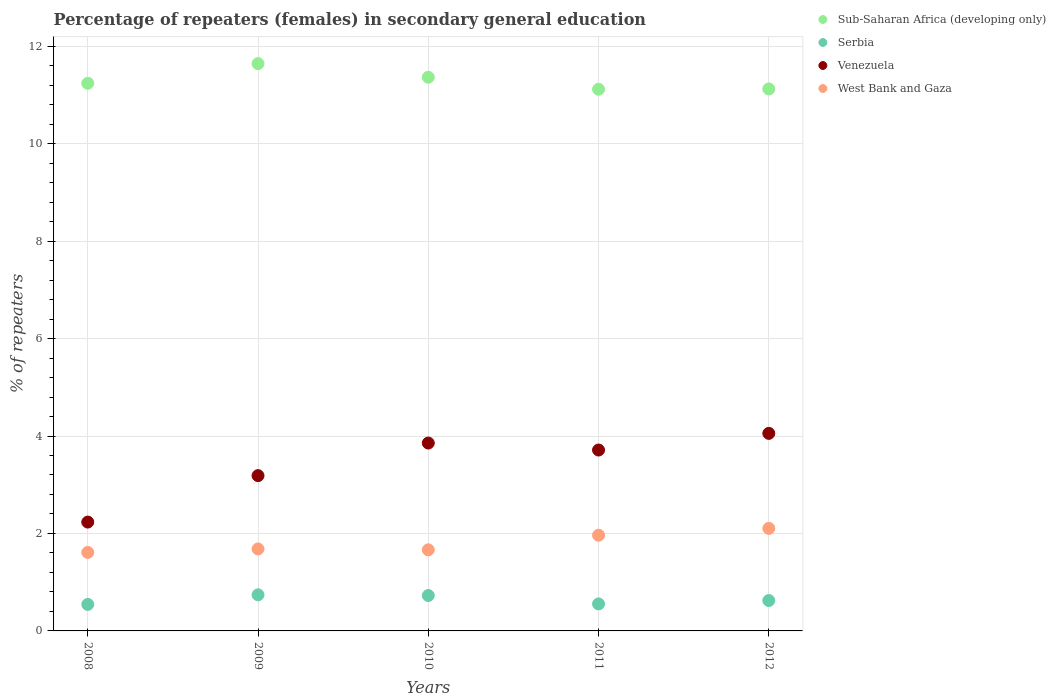How many different coloured dotlines are there?
Make the answer very short. 4. Is the number of dotlines equal to the number of legend labels?
Provide a short and direct response. Yes. What is the percentage of female repeaters in West Bank and Gaza in 2010?
Your answer should be compact. 1.66. Across all years, what is the maximum percentage of female repeaters in Serbia?
Keep it short and to the point. 0.74. Across all years, what is the minimum percentage of female repeaters in Venezuela?
Offer a terse response. 2.23. What is the total percentage of female repeaters in Venezuela in the graph?
Your response must be concise. 17.04. What is the difference between the percentage of female repeaters in West Bank and Gaza in 2009 and that in 2010?
Give a very brief answer. 0.02. What is the difference between the percentage of female repeaters in Serbia in 2012 and the percentage of female repeaters in Venezuela in 2009?
Provide a succinct answer. -2.56. What is the average percentage of female repeaters in Serbia per year?
Provide a succinct answer. 0.64. In the year 2008, what is the difference between the percentage of female repeaters in West Bank and Gaza and percentage of female repeaters in Sub-Saharan Africa (developing only)?
Your answer should be very brief. -9.63. In how many years, is the percentage of female repeaters in Sub-Saharan Africa (developing only) greater than 2.4 %?
Give a very brief answer. 5. What is the ratio of the percentage of female repeaters in West Bank and Gaza in 2009 to that in 2012?
Your response must be concise. 0.8. What is the difference between the highest and the second highest percentage of female repeaters in Sub-Saharan Africa (developing only)?
Make the answer very short. 0.28. What is the difference between the highest and the lowest percentage of female repeaters in West Bank and Gaza?
Provide a short and direct response. 0.49. Is it the case that in every year, the sum of the percentage of female repeaters in West Bank and Gaza and percentage of female repeaters in Sub-Saharan Africa (developing only)  is greater than the sum of percentage of female repeaters in Venezuela and percentage of female repeaters in Serbia?
Offer a very short reply. No. Does the percentage of female repeaters in Sub-Saharan Africa (developing only) monotonically increase over the years?
Provide a succinct answer. No. Is the percentage of female repeaters in Sub-Saharan Africa (developing only) strictly greater than the percentage of female repeaters in Venezuela over the years?
Your answer should be compact. Yes. Is the percentage of female repeaters in West Bank and Gaza strictly less than the percentage of female repeaters in Serbia over the years?
Your response must be concise. No. How many dotlines are there?
Ensure brevity in your answer.  4. How many years are there in the graph?
Your answer should be compact. 5. What is the difference between two consecutive major ticks on the Y-axis?
Provide a succinct answer. 2. Are the values on the major ticks of Y-axis written in scientific E-notation?
Offer a terse response. No. Does the graph contain any zero values?
Keep it short and to the point. No. Does the graph contain grids?
Keep it short and to the point. Yes. How many legend labels are there?
Keep it short and to the point. 4. How are the legend labels stacked?
Your response must be concise. Vertical. What is the title of the graph?
Your answer should be compact. Percentage of repeaters (females) in secondary general education. What is the label or title of the X-axis?
Make the answer very short. Years. What is the label or title of the Y-axis?
Give a very brief answer. % of repeaters. What is the % of repeaters in Sub-Saharan Africa (developing only) in 2008?
Provide a short and direct response. 11.24. What is the % of repeaters of Serbia in 2008?
Your response must be concise. 0.54. What is the % of repeaters in Venezuela in 2008?
Ensure brevity in your answer.  2.23. What is the % of repeaters in West Bank and Gaza in 2008?
Your answer should be compact. 1.61. What is the % of repeaters in Sub-Saharan Africa (developing only) in 2009?
Provide a short and direct response. 11.64. What is the % of repeaters in Serbia in 2009?
Provide a short and direct response. 0.74. What is the % of repeaters in Venezuela in 2009?
Keep it short and to the point. 3.19. What is the % of repeaters in West Bank and Gaza in 2009?
Your answer should be very brief. 1.68. What is the % of repeaters of Sub-Saharan Africa (developing only) in 2010?
Your response must be concise. 11.36. What is the % of repeaters in Serbia in 2010?
Give a very brief answer. 0.73. What is the % of repeaters in Venezuela in 2010?
Give a very brief answer. 3.86. What is the % of repeaters in West Bank and Gaza in 2010?
Offer a very short reply. 1.66. What is the % of repeaters of Sub-Saharan Africa (developing only) in 2011?
Your answer should be compact. 11.12. What is the % of repeaters of Serbia in 2011?
Give a very brief answer. 0.55. What is the % of repeaters in Venezuela in 2011?
Make the answer very short. 3.71. What is the % of repeaters of West Bank and Gaza in 2011?
Make the answer very short. 1.96. What is the % of repeaters of Sub-Saharan Africa (developing only) in 2012?
Give a very brief answer. 11.12. What is the % of repeaters in Serbia in 2012?
Make the answer very short. 0.62. What is the % of repeaters in Venezuela in 2012?
Provide a succinct answer. 4.05. What is the % of repeaters in West Bank and Gaza in 2012?
Your answer should be compact. 2.1. Across all years, what is the maximum % of repeaters of Sub-Saharan Africa (developing only)?
Offer a terse response. 11.64. Across all years, what is the maximum % of repeaters in Serbia?
Provide a short and direct response. 0.74. Across all years, what is the maximum % of repeaters in Venezuela?
Provide a succinct answer. 4.05. Across all years, what is the maximum % of repeaters in West Bank and Gaza?
Keep it short and to the point. 2.1. Across all years, what is the minimum % of repeaters of Sub-Saharan Africa (developing only)?
Ensure brevity in your answer.  11.12. Across all years, what is the minimum % of repeaters of Serbia?
Ensure brevity in your answer.  0.54. Across all years, what is the minimum % of repeaters of Venezuela?
Your response must be concise. 2.23. Across all years, what is the minimum % of repeaters in West Bank and Gaza?
Give a very brief answer. 1.61. What is the total % of repeaters of Sub-Saharan Africa (developing only) in the graph?
Offer a terse response. 56.48. What is the total % of repeaters in Serbia in the graph?
Your answer should be very brief. 3.19. What is the total % of repeaters of Venezuela in the graph?
Offer a very short reply. 17.04. What is the total % of repeaters in West Bank and Gaza in the graph?
Offer a very short reply. 9.03. What is the difference between the % of repeaters in Sub-Saharan Africa (developing only) in 2008 and that in 2009?
Provide a short and direct response. -0.4. What is the difference between the % of repeaters of Serbia in 2008 and that in 2009?
Make the answer very short. -0.2. What is the difference between the % of repeaters in Venezuela in 2008 and that in 2009?
Ensure brevity in your answer.  -0.95. What is the difference between the % of repeaters of West Bank and Gaza in 2008 and that in 2009?
Offer a very short reply. -0.07. What is the difference between the % of repeaters in Sub-Saharan Africa (developing only) in 2008 and that in 2010?
Ensure brevity in your answer.  -0.12. What is the difference between the % of repeaters in Serbia in 2008 and that in 2010?
Provide a succinct answer. -0.18. What is the difference between the % of repeaters of Venezuela in 2008 and that in 2010?
Offer a terse response. -1.62. What is the difference between the % of repeaters of West Bank and Gaza in 2008 and that in 2010?
Your response must be concise. -0.05. What is the difference between the % of repeaters of Sub-Saharan Africa (developing only) in 2008 and that in 2011?
Offer a terse response. 0.12. What is the difference between the % of repeaters in Serbia in 2008 and that in 2011?
Provide a short and direct response. -0.01. What is the difference between the % of repeaters in Venezuela in 2008 and that in 2011?
Make the answer very short. -1.48. What is the difference between the % of repeaters in West Bank and Gaza in 2008 and that in 2011?
Your response must be concise. -0.35. What is the difference between the % of repeaters of Sub-Saharan Africa (developing only) in 2008 and that in 2012?
Provide a succinct answer. 0.12. What is the difference between the % of repeaters in Serbia in 2008 and that in 2012?
Your answer should be very brief. -0.08. What is the difference between the % of repeaters in Venezuela in 2008 and that in 2012?
Your response must be concise. -1.82. What is the difference between the % of repeaters of West Bank and Gaza in 2008 and that in 2012?
Your answer should be very brief. -0.49. What is the difference between the % of repeaters of Sub-Saharan Africa (developing only) in 2009 and that in 2010?
Offer a terse response. 0.28. What is the difference between the % of repeaters in Serbia in 2009 and that in 2010?
Ensure brevity in your answer.  0.01. What is the difference between the % of repeaters of Venezuela in 2009 and that in 2010?
Make the answer very short. -0.67. What is the difference between the % of repeaters in West Bank and Gaza in 2009 and that in 2010?
Provide a succinct answer. 0.02. What is the difference between the % of repeaters in Sub-Saharan Africa (developing only) in 2009 and that in 2011?
Provide a succinct answer. 0.53. What is the difference between the % of repeaters of Serbia in 2009 and that in 2011?
Provide a succinct answer. 0.19. What is the difference between the % of repeaters of Venezuela in 2009 and that in 2011?
Ensure brevity in your answer.  -0.53. What is the difference between the % of repeaters in West Bank and Gaza in 2009 and that in 2011?
Offer a terse response. -0.28. What is the difference between the % of repeaters of Sub-Saharan Africa (developing only) in 2009 and that in 2012?
Provide a short and direct response. 0.52. What is the difference between the % of repeaters of Serbia in 2009 and that in 2012?
Offer a very short reply. 0.12. What is the difference between the % of repeaters of Venezuela in 2009 and that in 2012?
Keep it short and to the point. -0.87. What is the difference between the % of repeaters in West Bank and Gaza in 2009 and that in 2012?
Provide a succinct answer. -0.42. What is the difference between the % of repeaters of Sub-Saharan Africa (developing only) in 2010 and that in 2011?
Offer a terse response. 0.25. What is the difference between the % of repeaters in Serbia in 2010 and that in 2011?
Give a very brief answer. 0.17. What is the difference between the % of repeaters of Venezuela in 2010 and that in 2011?
Your answer should be compact. 0.14. What is the difference between the % of repeaters in West Bank and Gaza in 2010 and that in 2011?
Offer a very short reply. -0.3. What is the difference between the % of repeaters in Sub-Saharan Africa (developing only) in 2010 and that in 2012?
Offer a very short reply. 0.24. What is the difference between the % of repeaters of Serbia in 2010 and that in 2012?
Your answer should be compact. 0.1. What is the difference between the % of repeaters in Venezuela in 2010 and that in 2012?
Provide a succinct answer. -0.2. What is the difference between the % of repeaters in West Bank and Gaza in 2010 and that in 2012?
Ensure brevity in your answer.  -0.44. What is the difference between the % of repeaters of Sub-Saharan Africa (developing only) in 2011 and that in 2012?
Offer a terse response. -0.01. What is the difference between the % of repeaters of Serbia in 2011 and that in 2012?
Offer a terse response. -0.07. What is the difference between the % of repeaters in Venezuela in 2011 and that in 2012?
Ensure brevity in your answer.  -0.34. What is the difference between the % of repeaters in West Bank and Gaza in 2011 and that in 2012?
Your response must be concise. -0.14. What is the difference between the % of repeaters in Sub-Saharan Africa (developing only) in 2008 and the % of repeaters in Serbia in 2009?
Your response must be concise. 10.5. What is the difference between the % of repeaters of Sub-Saharan Africa (developing only) in 2008 and the % of repeaters of Venezuela in 2009?
Keep it short and to the point. 8.05. What is the difference between the % of repeaters of Sub-Saharan Africa (developing only) in 2008 and the % of repeaters of West Bank and Gaza in 2009?
Ensure brevity in your answer.  9.56. What is the difference between the % of repeaters in Serbia in 2008 and the % of repeaters in Venezuela in 2009?
Your answer should be compact. -2.64. What is the difference between the % of repeaters of Serbia in 2008 and the % of repeaters of West Bank and Gaza in 2009?
Your answer should be very brief. -1.14. What is the difference between the % of repeaters in Venezuela in 2008 and the % of repeaters in West Bank and Gaza in 2009?
Give a very brief answer. 0.55. What is the difference between the % of repeaters of Sub-Saharan Africa (developing only) in 2008 and the % of repeaters of Serbia in 2010?
Give a very brief answer. 10.51. What is the difference between the % of repeaters of Sub-Saharan Africa (developing only) in 2008 and the % of repeaters of Venezuela in 2010?
Offer a very short reply. 7.38. What is the difference between the % of repeaters in Sub-Saharan Africa (developing only) in 2008 and the % of repeaters in West Bank and Gaza in 2010?
Provide a short and direct response. 9.57. What is the difference between the % of repeaters of Serbia in 2008 and the % of repeaters of Venezuela in 2010?
Provide a succinct answer. -3.31. What is the difference between the % of repeaters of Serbia in 2008 and the % of repeaters of West Bank and Gaza in 2010?
Make the answer very short. -1.12. What is the difference between the % of repeaters in Venezuela in 2008 and the % of repeaters in West Bank and Gaza in 2010?
Ensure brevity in your answer.  0.57. What is the difference between the % of repeaters in Sub-Saharan Africa (developing only) in 2008 and the % of repeaters in Serbia in 2011?
Give a very brief answer. 10.68. What is the difference between the % of repeaters in Sub-Saharan Africa (developing only) in 2008 and the % of repeaters in Venezuela in 2011?
Give a very brief answer. 7.53. What is the difference between the % of repeaters of Sub-Saharan Africa (developing only) in 2008 and the % of repeaters of West Bank and Gaza in 2011?
Provide a succinct answer. 9.27. What is the difference between the % of repeaters in Serbia in 2008 and the % of repeaters in Venezuela in 2011?
Your answer should be very brief. -3.17. What is the difference between the % of repeaters of Serbia in 2008 and the % of repeaters of West Bank and Gaza in 2011?
Offer a terse response. -1.42. What is the difference between the % of repeaters of Venezuela in 2008 and the % of repeaters of West Bank and Gaza in 2011?
Give a very brief answer. 0.27. What is the difference between the % of repeaters of Sub-Saharan Africa (developing only) in 2008 and the % of repeaters of Serbia in 2012?
Provide a succinct answer. 10.62. What is the difference between the % of repeaters in Sub-Saharan Africa (developing only) in 2008 and the % of repeaters in Venezuela in 2012?
Your answer should be very brief. 7.18. What is the difference between the % of repeaters of Sub-Saharan Africa (developing only) in 2008 and the % of repeaters of West Bank and Gaza in 2012?
Ensure brevity in your answer.  9.13. What is the difference between the % of repeaters of Serbia in 2008 and the % of repeaters of Venezuela in 2012?
Make the answer very short. -3.51. What is the difference between the % of repeaters in Serbia in 2008 and the % of repeaters in West Bank and Gaza in 2012?
Offer a terse response. -1.56. What is the difference between the % of repeaters of Venezuela in 2008 and the % of repeaters of West Bank and Gaza in 2012?
Your response must be concise. 0.13. What is the difference between the % of repeaters of Sub-Saharan Africa (developing only) in 2009 and the % of repeaters of Serbia in 2010?
Provide a succinct answer. 10.92. What is the difference between the % of repeaters in Sub-Saharan Africa (developing only) in 2009 and the % of repeaters in Venezuela in 2010?
Provide a succinct answer. 7.79. What is the difference between the % of repeaters of Sub-Saharan Africa (developing only) in 2009 and the % of repeaters of West Bank and Gaza in 2010?
Give a very brief answer. 9.98. What is the difference between the % of repeaters of Serbia in 2009 and the % of repeaters of Venezuela in 2010?
Keep it short and to the point. -3.11. What is the difference between the % of repeaters in Serbia in 2009 and the % of repeaters in West Bank and Gaza in 2010?
Keep it short and to the point. -0.92. What is the difference between the % of repeaters of Venezuela in 2009 and the % of repeaters of West Bank and Gaza in 2010?
Provide a succinct answer. 1.52. What is the difference between the % of repeaters in Sub-Saharan Africa (developing only) in 2009 and the % of repeaters in Serbia in 2011?
Your answer should be compact. 11.09. What is the difference between the % of repeaters in Sub-Saharan Africa (developing only) in 2009 and the % of repeaters in Venezuela in 2011?
Your answer should be compact. 7.93. What is the difference between the % of repeaters of Sub-Saharan Africa (developing only) in 2009 and the % of repeaters of West Bank and Gaza in 2011?
Make the answer very short. 9.68. What is the difference between the % of repeaters in Serbia in 2009 and the % of repeaters in Venezuela in 2011?
Provide a succinct answer. -2.97. What is the difference between the % of repeaters of Serbia in 2009 and the % of repeaters of West Bank and Gaza in 2011?
Make the answer very short. -1.22. What is the difference between the % of repeaters of Venezuela in 2009 and the % of repeaters of West Bank and Gaza in 2011?
Make the answer very short. 1.22. What is the difference between the % of repeaters in Sub-Saharan Africa (developing only) in 2009 and the % of repeaters in Serbia in 2012?
Offer a terse response. 11.02. What is the difference between the % of repeaters of Sub-Saharan Africa (developing only) in 2009 and the % of repeaters of Venezuela in 2012?
Provide a short and direct response. 7.59. What is the difference between the % of repeaters of Sub-Saharan Africa (developing only) in 2009 and the % of repeaters of West Bank and Gaza in 2012?
Provide a succinct answer. 9.54. What is the difference between the % of repeaters in Serbia in 2009 and the % of repeaters in Venezuela in 2012?
Your answer should be very brief. -3.31. What is the difference between the % of repeaters of Serbia in 2009 and the % of repeaters of West Bank and Gaza in 2012?
Your response must be concise. -1.36. What is the difference between the % of repeaters in Venezuela in 2009 and the % of repeaters in West Bank and Gaza in 2012?
Offer a terse response. 1.08. What is the difference between the % of repeaters in Sub-Saharan Africa (developing only) in 2010 and the % of repeaters in Serbia in 2011?
Make the answer very short. 10.81. What is the difference between the % of repeaters of Sub-Saharan Africa (developing only) in 2010 and the % of repeaters of Venezuela in 2011?
Provide a succinct answer. 7.65. What is the difference between the % of repeaters in Sub-Saharan Africa (developing only) in 2010 and the % of repeaters in West Bank and Gaza in 2011?
Your response must be concise. 9.4. What is the difference between the % of repeaters of Serbia in 2010 and the % of repeaters of Venezuela in 2011?
Keep it short and to the point. -2.99. What is the difference between the % of repeaters of Serbia in 2010 and the % of repeaters of West Bank and Gaza in 2011?
Ensure brevity in your answer.  -1.24. What is the difference between the % of repeaters in Venezuela in 2010 and the % of repeaters in West Bank and Gaza in 2011?
Offer a very short reply. 1.89. What is the difference between the % of repeaters in Sub-Saharan Africa (developing only) in 2010 and the % of repeaters in Serbia in 2012?
Your answer should be compact. 10.74. What is the difference between the % of repeaters of Sub-Saharan Africa (developing only) in 2010 and the % of repeaters of Venezuela in 2012?
Your response must be concise. 7.31. What is the difference between the % of repeaters in Sub-Saharan Africa (developing only) in 2010 and the % of repeaters in West Bank and Gaza in 2012?
Give a very brief answer. 9.26. What is the difference between the % of repeaters in Serbia in 2010 and the % of repeaters in Venezuela in 2012?
Provide a short and direct response. -3.33. What is the difference between the % of repeaters of Serbia in 2010 and the % of repeaters of West Bank and Gaza in 2012?
Keep it short and to the point. -1.38. What is the difference between the % of repeaters in Venezuela in 2010 and the % of repeaters in West Bank and Gaza in 2012?
Give a very brief answer. 1.75. What is the difference between the % of repeaters in Sub-Saharan Africa (developing only) in 2011 and the % of repeaters in Serbia in 2012?
Provide a short and direct response. 10.49. What is the difference between the % of repeaters of Sub-Saharan Africa (developing only) in 2011 and the % of repeaters of Venezuela in 2012?
Your answer should be compact. 7.06. What is the difference between the % of repeaters of Sub-Saharan Africa (developing only) in 2011 and the % of repeaters of West Bank and Gaza in 2012?
Provide a short and direct response. 9.01. What is the difference between the % of repeaters in Serbia in 2011 and the % of repeaters in West Bank and Gaza in 2012?
Offer a terse response. -1.55. What is the difference between the % of repeaters of Venezuela in 2011 and the % of repeaters of West Bank and Gaza in 2012?
Offer a very short reply. 1.61. What is the average % of repeaters in Sub-Saharan Africa (developing only) per year?
Offer a very short reply. 11.3. What is the average % of repeaters of Serbia per year?
Your answer should be compact. 0.64. What is the average % of repeaters of Venezuela per year?
Keep it short and to the point. 3.41. What is the average % of repeaters of West Bank and Gaza per year?
Provide a succinct answer. 1.81. In the year 2008, what is the difference between the % of repeaters of Sub-Saharan Africa (developing only) and % of repeaters of Serbia?
Your response must be concise. 10.69. In the year 2008, what is the difference between the % of repeaters in Sub-Saharan Africa (developing only) and % of repeaters in Venezuela?
Your answer should be very brief. 9. In the year 2008, what is the difference between the % of repeaters in Sub-Saharan Africa (developing only) and % of repeaters in West Bank and Gaza?
Offer a terse response. 9.63. In the year 2008, what is the difference between the % of repeaters of Serbia and % of repeaters of Venezuela?
Your answer should be very brief. -1.69. In the year 2008, what is the difference between the % of repeaters of Serbia and % of repeaters of West Bank and Gaza?
Offer a very short reply. -1.07. In the year 2008, what is the difference between the % of repeaters in Venezuela and % of repeaters in West Bank and Gaza?
Provide a succinct answer. 0.62. In the year 2009, what is the difference between the % of repeaters in Sub-Saharan Africa (developing only) and % of repeaters in Serbia?
Provide a succinct answer. 10.9. In the year 2009, what is the difference between the % of repeaters of Sub-Saharan Africa (developing only) and % of repeaters of Venezuela?
Provide a short and direct response. 8.46. In the year 2009, what is the difference between the % of repeaters of Sub-Saharan Africa (developing only) and % of repeaters of West Bank and Gaza?
Offer a very short reply. 9.96. In the year 2009, what is the difference between the % of repeaters of Serbia and % of repeaters of Venezuela?
Ensure brevity in your answer.  -2.45. In the year 2009, what is the difference between the % of repeaters of Serbia and % of repeaters of West Bank and Gaza?
Provide a short and direct response. -0.94. In the year 2009, what is the difference between the % of repeaters in Venezuela and % of repeaters in West Bank and Gaza?
Your answer should be compact. 1.5. In the year 2010, what is the difference between the % of repeaters in Sub-Saharan Africa (developing only) and % of repeaters in Serbia?
Your answer should be compact. 10.64. In the year 2010, what is the difference between the % of repeaters in Sub-Saharan Africa (developing only) and % of repeaters in Venezuela?
Provide a short and direct response. 7.51. In the year 2010, what is the difference between the % of repeaters of Sub-Saharan Africa (developing only) and % of repeaters of West Bank and Gaza?
Your answer should be compact. 9.7. In the year 2010, what is the difference between the % of repeaters of Serbia and % of repeaters of Venezuela?
Offer a very short reply. -3.13. In the year 2010, what is the difference between the % of repeaters of Serbia and % of repeaters of West Bank and Gaza?
Give a very brief answer. -0.94. In the year 2010, what is the difference between the % of repeaters of Venezuela and % of repeaters of West Bank and Gaza?
Offer a very short reply. 2.19. In the year 2011, what is the difference between the % of repeaters of Sub-Saharan Africa (developing only) and % of repeaters of Serbia?
Give a very brief answer. 10.56. In the year 2011, what is the difference between the % of repeaters of Sub-Saharan Africa (developing only) and % of repeaters of Venezuela?
Offer a very short reply. 7.4. In the year 2011, what is the difference between the % of repeaters in Sub-Saharan Africa (developing only) and % of repeaters in West Bank and Gaza?
Make the answer very short. 9.15. In the year 2011, what is the difference between the % of repeaters of Serbia and % of repeaters of Venezuela?
Your answer should be compact. -3.16. In the year 2011, what is the difference between the % of repeaters of Serbia and % of repeaters of West Bank and Gaza?
Your answer should be compact. -1.41. In the year 2011, what is the difference between the % of repeaters of Venezuela and % of repeaters of West Bank and Gaza?
Make the answer very short. 1.75. In the year 2012, what is the difference between the % of repeaters of Sub-Saharan Africa (developing only) and % of repeaters of Serbia?
Your response must be concise. 10.5. In the year 2012, what is the difference between the % of repeaters in Sub-Saharan Africa (developing only) and % of repeaters in Venezuela?
Your answer should be very brief. 7.07. In the year 2012, what is the difference between the % of repeaters of Sub-Saharan Africa (developing only) and % of repeaters of West Bank and Gaza?
Offer a very short reply. 9.02. In the year 2012, what is the difference between the % of repeaters of Serbia and % of repeaters of Venezuela?
Make the answer very short. -3.43. In the year 2012, what is the difference between the % of repeaters in Serbia and % of repeaters in West Bank and Gaza?
Keep it short and to the point. -1.48. In the year 2012, what is the difference between the % of repeaters in Venezuela and % of repeaters in West Bank and Gaza?
Provide a short and direct response. 1.95. What is the ratio of the % of repeaters in Sub-Saharan Africa (developing only) in 2008 to that in 2009?
Your response must be concise. 0.97. What is the ratio of the % of repeaters of Serbia in 2008 to that in 2009?
Offer a terse response. 0.73. What is the ratio of the % of repeaters in Venezuela in 2008 to that in 2009?
Offer a very short reply. 0.7. What is the ratio of the % of repeaters of West Bank and Gaza in 2008 to that in 2009?
Your answer should be compact. 0.96. What is the ratio of the % of repeaters of Sub-Saharan Africa (developing only) in 2008 to that in 2010?
Offer a very short reply. 0.99. What is the ratio of the % of repeaters in Serbia in 2008 to that in 2010?
Ensure brevity in your answer.  0.75. What is the ratio of the % of repeaters in Venezuela in 2008 to that in 2010?
Make the answer very short. 0.58. What is the ratio of the % of repeaters in West Bank and Gaza in 2008 to that in 2010?
Your answer should be compact. 0.97. What is the ratio of the % of repeaters in Sub-Saharan Africa (developing only) in 2008 to that in 2011?
Offer a very short reply. 1.01. What is the ratio of the % of repeaters of Serbia in 2008 to that in 2011?
Ensure brevity in your answer.  0.98. What is the ratio of the % of repeaters of Venezuela in 2008 to that in 2011?
Keep it short and to the point. 0.6. What is the ratio of the % of repeaters in West Bank and Gaza in 2008 to that in 2011?
Offer a very short reply. 0.82. What is the ratio of the % of repeaters in Sub-Saharan Africa (developing only) in 2008 to that in 2012?
Keep it short and to the point. 1.01. What is the ratio of the % of repeaters of Serbia in 2008 to that in 2012?
Offer a terse response. 0.87. What is the ratio of the % of repeaters in Venezuela in 2008 to that in 2012?
Provide a short and direct response. 0.55. What is the ratio of the % of repeaters of West Bank and Gaza in 2008 to that in 2012?
Make the answer very short. 0.77. What is the ratio of the % of repeaters of Sub-Saharan Africa (developing only) in 2009 to that in 2010?
Ensure brevity in your answer.  1.02. What is the ratio of the % of repeaters of Serbia in 2009 to that in 2010?
Keep it short and to the point. 1.02. What is the ratio of the % of repeaters in Venezuela in 2009 to that in 2010?
Keep it short and to the point. 0.83. What is the ratio of the % of repeaters in West Bank and Gaza in 2009 to that in 2010?
Offer a very short reply. 1.01. What is the ratio of the % of repeaters of Sub-Saharan Africa (developing only) in 2009 to that in 2011?
Your response must be concise. 1.05. What is the ratio of the % of repeaters in Serbia in 2009 to that in 2011?
Your answer should be compact. 1.34. What is the ratio of the % of repeaters in Venezuela in 2009 to that in 2011?
Provide a succinct answer. 0.86. What is the ratio of the % of repeaters in West Bank and Gaza in 2009 to that in 2011?
Your answer should be compact. 0.86. What is the ratio of the % of repeaters in Sub-Saharan Africa (developing only) in 2009 to that in 2012?
Offer a very short reply. 1.05. What is the ratio of the % of repeaters of Serbia in 2009 to that in 2012?
Give a very brief answer. 1.19. What is the ratio of the % of repeaters of Venezuela in 2009 to that in 2012?
Give a very brief answer. 0.79. What is the ratio of the % of repeaters in West Bank and Gaza in 2009 to that in 2012?
Offer a very short reply. 0.8. What is the ratio of the % of repeaters in Sub-Saharan Africa (developing only) in 2010 to that in 2011?
Your answer should be very brief. 1.02. What is the ratio of the % of repeaters of Serbia in 2010 to that in 2011?
Offer a terse response. 1.31. What is the ratio of the % of repeaters of Venezuela in 2010 to that in 2011?
Give a very brief answer. 1.04. What is the ratio of the % of repeaters of West Bank and Gaza in 2010 to that in 2011?
Your answer should be compact. 0.85. What is the ratio of the % of repeaters in Sub-Saharan Africa (developing only) in 2010 to that in 2012?
Provide a succinct answer. 1.02. What is the ratio of the % of repeaters in Serbia in 2010 to that in 2012?
Provide a succinct answer. 1.17. What is the ratio of the % of repeaters in Venezuela in 2010 to that in 2012?
Offer a terse response. 0.95. What is the ratio of the % of repeaters of West Bank and Gaza in 2010 to that in 2012?
Keep it short and to the point. 0.79. What is the ratio of the % of repeaters in Sub-Saharan Africa (developing only) in 2011 to that in 2012?
Make the answer very short. 1. What is the ratio of the % of repeaters in Serbia in 2011 to that in 2012?
Provide a short and direct response. 0.89. What is the ratio of the % of repeaters of Venezuela in 2011 to that in 2012?
Provide a succinct answer. 0.92. What is the ratio of the % of repeaters in West Bank and Gaza in 2011 to that in 2012?
Make the answer very short. 0.93. What is the difference between the highest and the second highest % of repeaters of Sub-Saharan Africa (developing only)?
Your response must be concise. 0.28. What is the difference between the highest and the second highest % of repeaters in Serbia?
Offer a terse response. 0.01. What is the difference between the highest and the second highest % of repeaters of Venezuela?
Provide a succinct answer. 0.2. What is the difference between the highest and the second highest % of repeaters in West Bank and Gaza?
Your answer should be very brief. 0.14. What is the difference between the highest and the lowest % of repeaters of Sub-Saharan Africa (developing only)?
Offer a terse response. 0.53. What is the difference between the highest and the lowest % of repeaters in Serbia?
Give a very brief answer. 0.2. What is the difference between the highest and the lowest % of repeaters of Venezuela?
Offer a very short reply. 1.82. What is the difference between the highest and the lowest % of repeaters of West Bank and Gaza?
Provide a short and direct response. 0.49. 